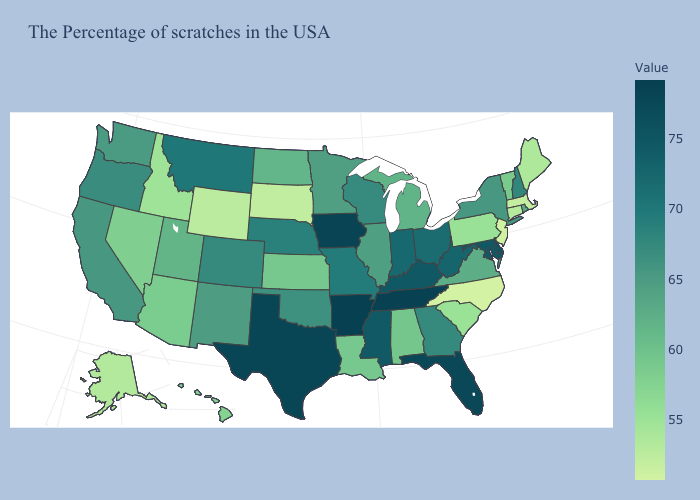Does Colorado have the lowest value in the West?
Short answer required. No. Does Kentucky have a lower value than North Dakota?
Give a very brief answer. No. Which states have the lowest value in the MidWest?
Concise answer only. South Dakota. Does Vermont have a lower value than Pennsylvania?
Be succinct. No. Among the states that border Vermont , which have the highest value?
Give a very brief answer. New Hampshire. 